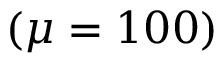<formula> <loc_0><loc_0><loc_500><loc_500>( \mu = 1 0 0 )</formula> 